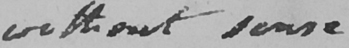Can you read and transcribe this handwriting? without sense 